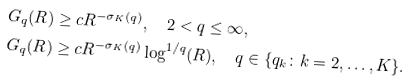Convert formula to latex. <formula><loc_0><loc_0><loc_500><loc_500>G _ { q } ( R ) & \geq c R ^ { - \sigma _ { K } ( q ) } , \quad 2 < q \leq \infty , \\ G _ { q } ( R ) & \geq c R ^ { - \sigma _ { K } ( q ) } \log ^ { 1 / q } ( R ) , \quad q \in \{ q _ { k } \colon k = 2 , \dots , K \} .</formula> 